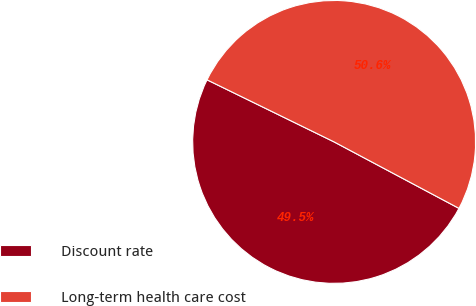Convert chart. <chart><loc_0><loc_0><loc_500><loc_500><pie_chart><fcel>Discount rate<fcel>Long-term health care cost<nl><fcel>49.45%<fcel>50.55%<nl></chart> 